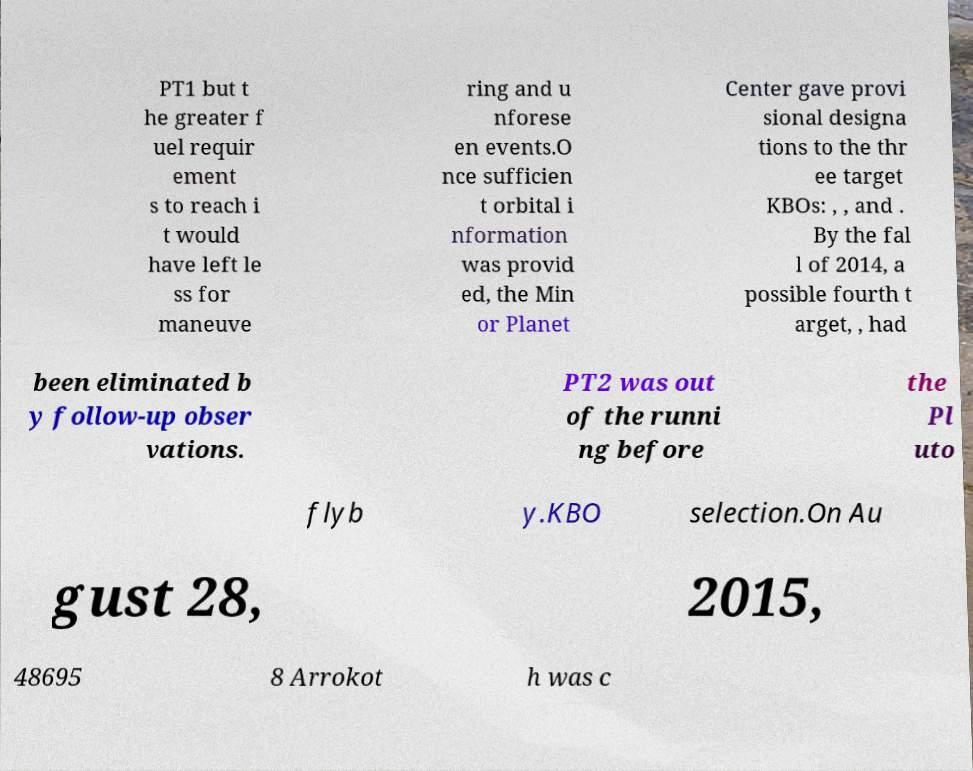What messages or text are displayed in this image? I need them in a readable, typed format. PT1 but t he greater f uel requir ement s to reach i t would have left le ss for maneuve ring and u nforese en events.O nce sufficien t orbital i nformation was provid ed, the Min or Planet Center gave provi sional designa tions to the thr ee target KBOs: , , and . By the fal l of 2014, a possible fourth t arget, , had been eliminated b y follow-up obser vations. PT2 was out of the runni ng before the Pl uto flyb y.KBO selection.On Au gust 28, 2015, 48695 8 Arrokot h was c 